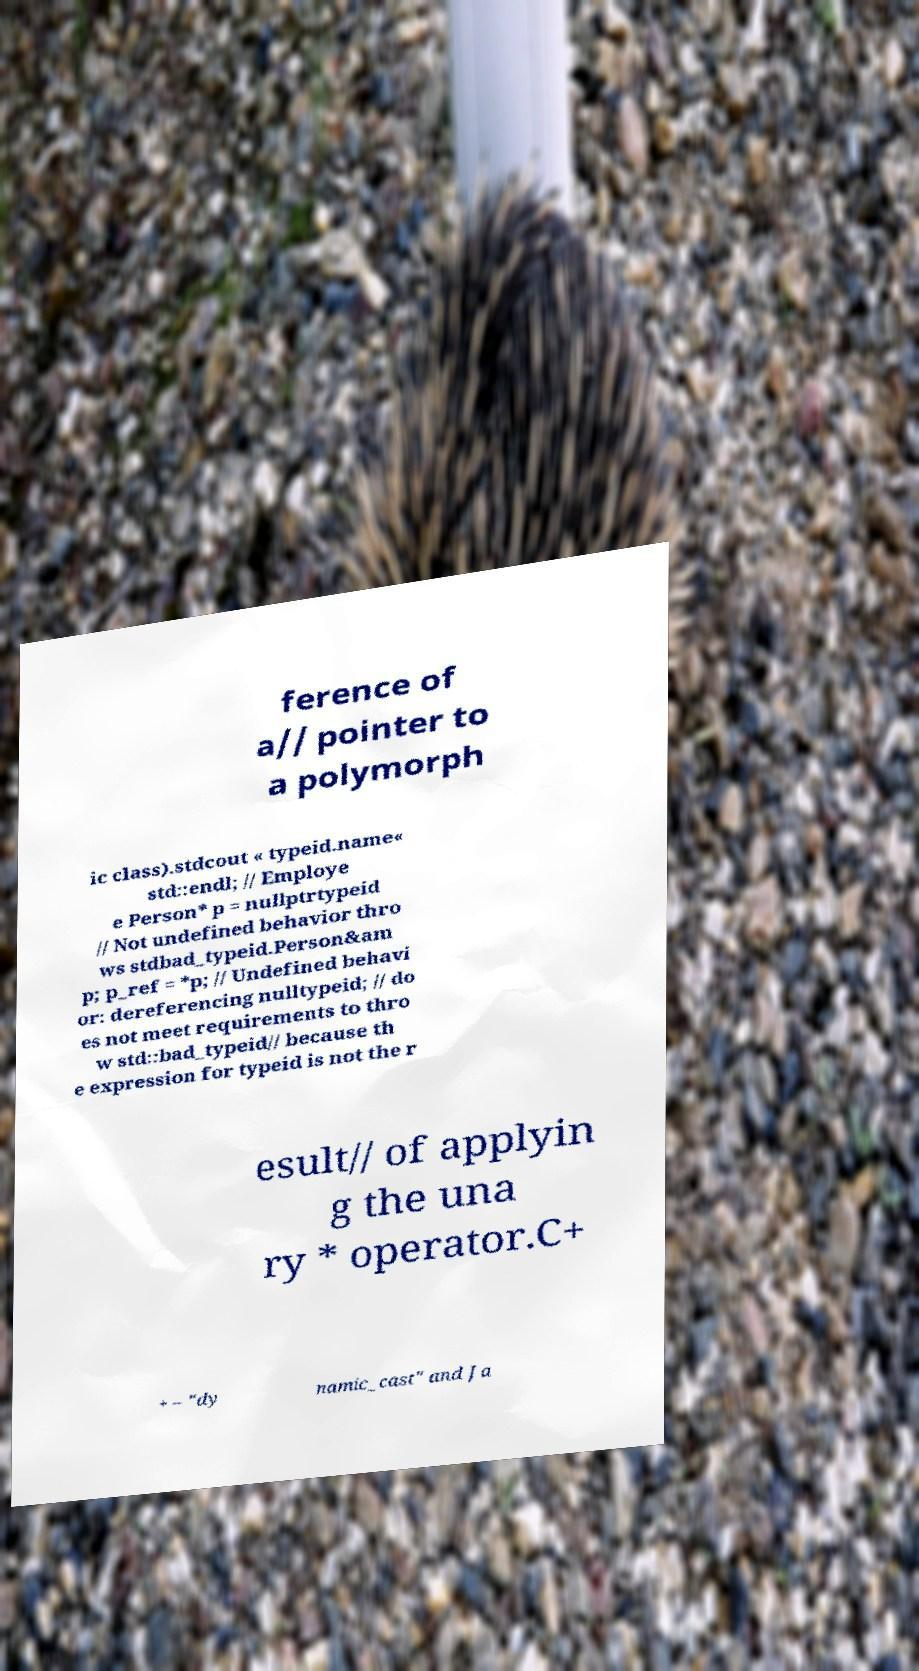There's text embedded in this image that I need extracted. Can you transcribe it verbatim? ference of a// pointer to a polymorph ic class).stdcout « typeid.name« std::endl; // Employe e Person* p = nullptrtypeid // Not undefined behavior thro ws stdbad_typeid.Person&am p; p_ref = *p; // Undefined behavi or: dereferencing nulltypeid; // do es not meet requirements to thro w std::bad_typeid// because th e expression for typeid is not the r esult// of applyin g the una ry * operator.C+ + – "dy namic_cast" and Ja 